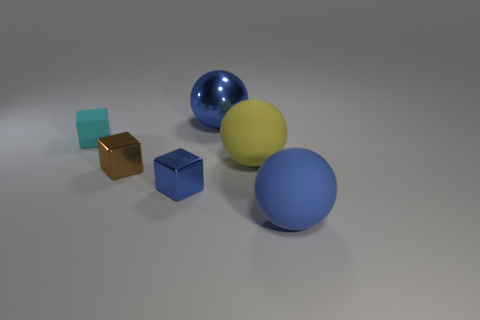What number of large things are red matte objects or blue things? In the image, there are no large red matte objects, but there are two large blue items—a sphere and a cube. Therefore, the accurate count of large red matte objects or blue things is two. 